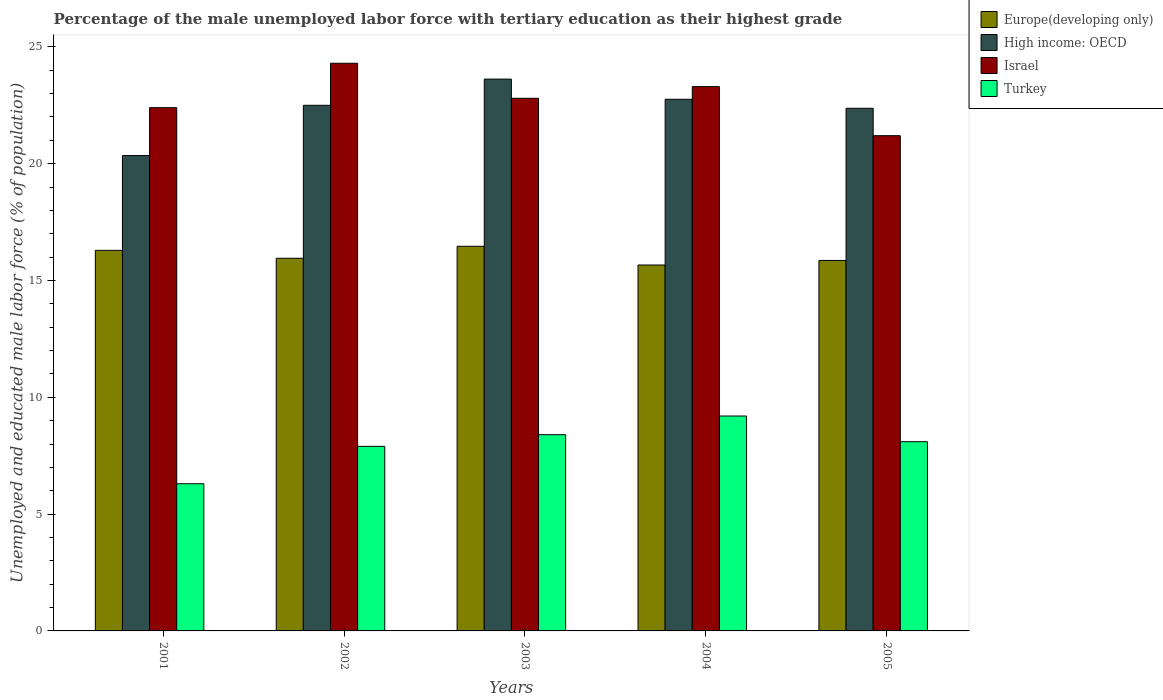How many different coloured bars are there?
Offer a terse response. 4. Are the number of bars per tick equal to the number of legend labels?
Offer a terse response. Yes. Are the number of bars on each tick of the X-axis equal?
Your answer should be very brief. Yes. How many bars are there on the 3rd tick from the left?
Make the answer very short. 4. What is the label of the 5th group of bars from the left?
Make the answer very short. 2005. In how many cases, is the number of bars for a given year not equal to the number of legend labels?
Your response must be concise. 0. What is the percentage of the unemployed male labor force with tertiary education in Europe(developing only) in 2002?
Provide a succinct answer. 15.95. Across all years, what is the maximum percentage of the unemployed male labor force with tertiary education in Turkey?
Your response must be concise. 9.2. Across all years, what is the minimum percentage of the unemployed male labor force with tertiary education in Israel?
Ensure brevity in your answer.  21.2. What is the total percentage of the unemployed male labor force with tertiary education in High income: OECD in the graph?
Provide a short and direct response. 111.6. What is the difference between the percentage of the unemployed male labor force with tertiary education in Israel in 2002 and that in 2005?
Offer a very short reply. 3.1. What is the difference between the percentage of the unemployed male labor force with tertiary education in Turkey in 2001 and the percentage of the unemployed male labor force with tertiary education in Europe(developing only) in 2002?
Your answer should be compact. -9.65. What is the average percentage of the unemployed male labor force with tertiary education in Israel per year?
Your answer should be compact. 22.8. In the year 2002, what is the difference between the percentage of the unemployed male labor force with tertiary education in High income: OECD and percentage of the unemployed male labor force with tertiary education in Europe(developing only)?
Make the answer very short. 6.55. In how many years, is the percentage of the unemployed male labor force with tertiary education in Turkey greater than 2 %?
Keep it short and to the point. 5. What is the ratio of the percentage of the unemployed male labor force with tertiary education in Israel in 2004 to that in 2005?
Your response must be concise. 1.1. Is the percentage of the unemployed male labor force with tertiary education in Europe(developing only) in 2002 less than that in 2005?
Your answer should be very brief. No. What is the difference between the highest and the second highest percentage of the unemployed male labor force with tertiary education in Turkey?
Provide a short and direct response. 0.8. What is the difference between the highest and the lowest percentage of the unemployed male labor force with tertiary education in Europe(developing only)?
Ensure brevity in your answer.  0.8. Is the sum of the percentage of the unemployed male labor force with tertiary education in Israel in 2003 and 2005 greater than the maximum percentage of the unemployed male labor force with tertiary education in Turkey across all years?
Give a very brief answer. Yes. Is it the case that in every year, the sum of the percentage of the unemployed male labor force with tertiary education in Europe(developing only) and percentage of the unemployed male labor force with tertiary education in Turkey is greater than the sum of percentage of the unemployed male labor force with tertiary education in High income: OECD and percentage of the unemployed male labor force with tertiary education in Israel?
Offer a terse response. No. What does the 2nd bar from the left in 2002 represents?
Your answer should be compact. High income: OECD. What does the 2nd bar from the right in 2002 represents?
Offer a very short reply. Israel. Is it the case that in every year, the sum of the percentage of the unemployed male labor force with tertiary education in High income: OECD and percentage of the unemployed male labor force with tertiary education in Europe(developing only) is greater than the percentage of the unemployed male labor force with tertiary education in Israel?
Offer a terse response. Yes. Are all the bars in the graph horizontal?
Your response must be concise. No. How many years are there in the graph?
Ensure brevity in your answer.  5. What is the difference between two consecutive major ticks on the Y-axis?
Offer a terse response. 5. Are the values on the major ticks of Y-axis written in scientific E-notation?
Your response must be concise. No. Does the graph contain any zero values?
Your answer should be very brief. No. Does the graph contain grids?
Provide a short and direct response. No. Where does the legend appear in the graph?
Your answer should be compact. Top right. What is the title of the graph?
Ensure brevity in your answer.  Percentage of the male unemployed labor force with tertiary education as their highest grade. What is the label or title of the Y-axis?
Your answer should be compact. Unemployed and educated male labor force (% of population). What is the Unemployed and educated male labor force (% of population) of Europe(developing only) in 2001?
Your answer should be compact. 16.29. What is the Unemployed and educated male labor force (% of population) in High income: OECD in 2001?
Ensure brevity in your answer.  20.35. What is the Unemployed and educated male labor force (% of population) of Israel in 2001?
Offer a very short reply. 22.4. What is the Unemployed and educated male labor force (% of population) of Turkey in 2001?
Ensure brevity in your answer.  6.3. What is the Unemployed and educated male labor force (% of population) of Europe(developing only) in 2002?
Your response must be concise. 15.95. What is the Unemployed and educated male labor force (% of population) of High income: OECD in 2002?
Make the answer very short. 22.5. What is the Unemployed and educated male labor force (% of population) of Israel in 2002?
Give a very brief answer. 24.3. What is the Unemployed and educated male labor force (% of population) of Turkey in 2002?
Offer a very short reply. 7.9. What is the Unemployed and educated male labor force (% of population) of Europe(developing only) in 2003?
Your response must be concise. 16.46. What is the Unemployed and educated male labor force (% of population) of High income: OECD in 2003?
Your response must be concise. 23.62. What is the Unemployed and educated male labor force (% of population) of Israel in 2003?
Offer a terse response. 22.8. What is the Unemployed and educated male labor force (% of population) in Turkey in 2003?
Provide a short and direct response. 8.4. What is the Unemployed and educated male labor force (% of population) of Europe(developing only) in 2004?
Your response must be concise. 15.66. What is the Unemployed and educated male labor force (% of population) in High income: OECD in 2004?
Your answer should be compact. 22.76. What is the Unemployed and educated male labor force (% of population) in Israel in 2004?
Make the answer very short. 23.3. What is the Unemployed and educated male labor force (% of population) of Turkey in 2004?
Keep it short and to the point. 9.2. What is the Unemployed and educated male labor force (% of population) of Europe(developing only) in 2005?
Provide a short and direct response. 15.86. What is the Unemployed and educated male labor force (% of population) of High income: OECD in 2005?
Give a very brief answer. 22.37. What is the Unemployed and educated male labor force (% of population) of Israel in 2005?
Keep it short and to the point. 21.2. What is the Unemployed and educated male labor force (% of population) of Turkey in 2005?
Your answer should be compact. 8.1. Across all years, what is the maximum Unemployed and educated male labor force (% of population) of Europe(developing only)?
Provide a short and direct response. 16.46. Across all years, what is the maximum Unemployed and educated male labor force (% of population) in High income: OECD?
Ensure brevity in your answer.  23.62. Across all years, what is the maximum Unemployed and educated male labor force (% of population) in Israel?
Your answer should be very brief. 24.3. Across all years, what is the maximum Unemployed and educated male labor force (% of population) of Turkey?
Ensure brevity in your answer.  9.2. Across all years, what is the minimum Unemployed and educated male labor force (% of population) of Europe(developing only)?
Provide a short and direct response. 15.66. Across all years, what is the minimum Unemployed and educated male labor force (% of population) in High income: OECD?
Your answer should be very brief. 20.35. Across all years, what is the minimum Unemployed and educated male labor force (% of population) of Israel?
Offer a terse response. 21.2. Across all years, what is the minimum Unemployed and educated male labor force (% of population) of Turkey?
Give a very brief answer. 6.3. What is the total Unemployed and educated male labor force (% of population) in Europe(developing only) in the graph?
Offer a terse response. 80.23. What is the total Unemployed and educated male labor force (% of population) in High income: OECD in the graph?
Your answer should be compact. 111.6. What is the total Unemployed and educated male labor force (% of population) in Israel in the graph?
Provide a short and direct response. 114. What is the total Unemployed and educated male labor force (% of population) in Turkey in the graph?
Provide a short and direct response. 39.9. What is the difference between the Unemployed and educated male labor force (% of population) of Europe(developing only) in 2001 and that in 2002?
Your answer should be compact. 0.34. What is the difference between the Unemployed and educated male labor force (% of population) of High income: OECD in 2001 and that in 2002?
Provide a short and direct response. -2.15. What is the difference between the Unemployed and educated male labor force (% of population) in Israel in 2001 and that in 2002?
Offer a terse response. -1.9. What is the difference between the Unemployed and educated male labor force (% of population) in Europe(developing only) in 2001 and that in 2003?
Your answer should be compact. -0.17. What is the difference between the Unemployed and educated male labor force (% of population) in High income: OECD in 2001 and that in 2003?
Keep it short and to the point. -3.27. What is the difference between the Unemployed and educated male labor force (% of population) of Turkey in 2001 and that in 2003?
Keep it short and to the point. -2.1. What is the difference between the Unemployed and educated male labor force (% of population) in Europe(developing only) in 2001 and that in 2004?
Your response must be concise. 0.63. What is the difference between the Unemployed and educated male labor force (% of population) of High income: OECD in 2001 and that in 2004?
Ensure brevity in your answer.  -2.41. What is the difference between the Unemployed and educated male labor force (% of population) in Israel in 2001 and that in 2004?
Make the answer very short. -0.9. What is the difference between the Unemployed and educated male labor force (% of population) of Europe(developing only) in 2001 and that in 2005?
Offer a terse response. 0.43. What is the difference between the Unemployed and educated male labor force (% of population) of High income: OECD in 2001 and that in 2005?
Make the answer very short. -2.02. What is the difference between the Unemployed and educated male labor force (% of population) of Israel in 2001 and that in 2005?
Provide a succinct answer. 1.2. What is the difference between the Unemployed and educated male labor force (% of population) of Turkey in 2001 and that in 2005?
Give a very brief answer. -1.8. What is the difference between the Unemployed and educated male labor force (% of population) of Europe(developing only) in 2002 and that in 2003?
Your answer should be very brief. -0.51. What is the difference between the Unemployed and educated male labor force (% of population) of High income: OECD in 2002 and that in 2003?
Provide a succinct answer. -1.12. What is the difference between the Unemployed and educated male labor force (% of population) in Turkey in 2002 and that in 2003?
Offer a very short reply. -0.5. What is the difference between the Unemployed and educated male labor force (% of population) in Europe(developing only) in 2002 and that in 2004?
Your answer should be compact. 0.29. What is the difference between the Unemployed and educated male labor force (% of population) of High income: OECD in 2002 and that in 2004?
Offer a very short reply. -0.26. What is the difference between the Unemployed and educated male labor force (% of population) in Israel in 2002 and that in 2004?
Offer a very short reply. 1. What is the difference between the Unemployed and educated male labor force (% of population) in Turkey in 2002 and that in 2004?
Provide a succinct answer. -1.3. What is the difference between the Unemployed and educated male labor force (% of population) of Europe(developing only) in 2002 and that in 2005?
Your answer should be compact. 0.09. What is the difference between the Unemployed and educated male labor force (% of population) in High income: OECD in 2002 and that in 2005?
Make the answer very short. 0.13. What is the difference between the Unemployed and educated male labor force (% of population) in Israel in 2002 and that in 2005?
Offer a very short reply. 3.1. What is the difference between the Unemployed and educated male labor force (% of population) in Turkey in 2002 and that in 2005?
Your answer should be very brief. -0.2. What is the difference between the Unemployed and educated male labor force (% of population) of Europe(developing only) in 2003 and that in 2004?
Provide a short and direct response. 0.8. What is the difference between the Unemployed and educated male labor force (% of population) of High income: OECD in 2003 and that in 2004?
Provide a short and direct response. 0.86. What is the difference between the Unemployed and educated male labor force (% of population) in Europe(developing only) in 2003 and that in 2005?
Provide a short and direct response. 0.61. What is the difference between the Unemployed and educated male labor force (% of population) in High income: OECD in 2003 and that in 2005?
Your answer should be very brief. 1.25. What is the difference between the Unemployed and educated male labor force (% of population) in Turkey in 2003 and that in 2005?
Offer a terse response. 0.3. What is the difference between the Unemployed and educated male labor force (% of population) in Europe(developing only) in 2004 and that in 2005?
Offer a very short reply. -0.2. What is the difference between the Unemployed and educated male labor force (% of population) in High income: OECD in 2004 and that in 2005?
Offer a terse response. 0.39. What is the difference between the Unemployed and educated male labor force (% of population) in Israel in 2004 and that in 2005?
Give a very brief answer. 2.1. What is the difference between the Unemployed and educated male labor force (% of population) in Turkey in 2004 and that in 2005?
Make the answer very short. 1.1. What is the difference between the Unemployed and educated male labor force (% of population) of Europe(developing only) in 2001 and the Unemployed and educated male labor force (% of population) of High income: OECD in 2002?
Your answer should be compact. -6.21. What is the difference between the Unemployed and educated male labor force (% of population) of Europe(developing only) in 2001 and the Unemployed and educated male labor force (% of population) of Israel in 2002?
Offer a very short reply. -8.01. What is the difference between the Unemployed and educated male labor force (% of population) in Europe(developing only) in 2001 and the Unemployed and educated male labor force (% of population) in Turkey in 2002?
Offer a terse response. 8.39. What is the difference between the Unemployed and educated male labor force (% of population) in High income: OECD in 2001 and the Unemployed and educated male labor force (% of population) in Israel in 2002?
Make the answer very short. -3.95. What is the difference between the Unemployed and educated male labor force (% of population) in High income: OECD in 2001 and the Unemployed and educated male labor force (% of population) in Turkey in 2002?
Keep it short and to the point. 12.45. What is the difference between the Unemployed and educated male labor force (% of population) of Israel in 2001 and the Unemployed and educated male labor force (% of population) of Turkey in 2002?
Your response must be concise. 14.5. What is the difference between the Unemployed and educated male labor force (% of population) of Europe(developing only) in 2001 and the Unemployed and educated male labor force (% of population) of High income: OECD in 2003?
Offer a terse response. -7.33. What is the difference between the Unemployed and educated male labor force (% of population) in Europe(developing only) in 2001 and the Unemployed and educated male labor force (% of population) in Israel in 2003?
Your answer should be very brief. -6.51. What is the difference between the Unemployed and educated male labor force (% of population) in Europe(developing only) in 2001 and the Unemployed and educated male labor force (% of population) in Turkey in 2003?
Your answer should be very brief. 7.89. What is the difference between the Unemployed and educated male labor force (% of population) in High income: OECD in 2001 and the Unemployed and educated male labor force (% of population) in Israel in 2003?
Provide a succinct answer. -2.45. What is the difference between the Unemployed and educated male labor force (% of population) of High income: OECD in 2001 and the Unemployed and educated male labor force (% of population) of Turkey in 2003?
Your answer should be compact. 11.95. What is the difference between the Unemployed and educated male labor force (% of population) in Europe(developing only) in 2001 and the Unemployed and educated male labor force (% of population) in High income: OECD in 2004?
Ensure brevity in your answer.  -6.47. What is the difference between the Unemployed and educated male labor force (% of population) of Europe(developing only) in 2001 and the Unemployed and educated male labor force (% of population) of Israel in 2004?
Give a very brief answer. -7.01. What is the difference between the Unemployed and educated male labor force (% of population) in Europe(developing only) in 2001 and the Unemployed and educated male labor force (% of population) in Turkey in 2004?
Ensure brevity in your answer.  7.09. What is the difference between the Unemployed and educated male labor force (% of population) in High income: OECD in 2001 and the Unemployed and educated male labor force (% of population) in Israel in 2004?
Offer a terse response. -2.95. What is the difference between the Unemployed and educated male labor force (% of population) in High income: OECD in 2001 and the Unemployed and educated male labor force (% of population) in Turkey in 2004?
Your answer should be very brief. 11.15. What is the difference between the Unemployed and educated male labor force (% of population) of Israel in 2001 and the Unemployed and educated male labor force (% of population) of Turkey in 2004?
Your answer should be compact. 13.2. What is the difference between the Unemployed and educated male labor force (% of population) in Europe(developing only) in 2001 and the Unemployed and educated male labor force (% of population) in High income: OECD in 2005?
Offer a terse response. -6.08. What is the difference between the Unemployed and educated male labor force (% of population) of Europe(developing only) in 2001 and the Unemployed and educated male labor force (% of population) of Israel in 2005?
Provide a short and direct response. -4.91. What is the difference between the Unemployed and educated male labor force (% of population) in Europe(developing only) in 2001 and the Unemployed and educated male labor force (% of population) in Turkey in 2005?
Your answer should be very brief. 8.19. What is the difference between the Unemployed and educated male labor force (% of population) of High income: OECD in 2001 and the Unemployed and educated male labor force (% of population) of Israel in 2005?
Keep it short and to the point. -0.85. What is the difference between the Unemployed and educated male labor force (% of population) in High income: OECD in 2001 and the Unemployed and educated male labor force (% of population) in Turkey in 2005?
Your response must be concise. 12.25. What is the difference between the Unemployed and educated male labor force (% of population) in Israel in 2001 and the Unemployed and educated male labor force (% of population) in Turkey in 2005?
Provide a succinct answer. 14.3. What is the difference between the Unemployed and educated male labor force (% of population) of Europe(developing only) in 2002 and the Unemployed and educated male labor force (% of population) of High income: OECD in 2003?
Make the answer very short. -7.67. What is the difference between the Unemployed and educated male labor force (% of population) in Europe(developing only) in 2002 and the Unemployed and educated male labor force (% of population) in Israel in 2003?
Your response must be concise. -6.85. What is the difference between the Unemployed and educated male labor force (% of population) of Europe(developing only) in 2002 and the Unemployed and educated male labor force (% of population) of Turkey in 2003?
Offer a very short reply. 7.55. What is the difference between the Unemployed and educated male labor force (% of population) of High income: OECD in 2002 and the Unemployed and educated male labor force (% of population) of Israel in 2003?
Provide a succinct answer. -0.3. What is the difference between the Unemployed and educated male labor force (% of population) in High income: OECD in 2002 and the Unemployed and educated male labor force (% of population) in Turkey in 2003?
Make the answer very short. 14.1. What is the difference between the Unemployed and educated male labor force (% of population) of Europe(developing only) in 2002 and the Unemployed and educated male labor force (% of population) of High income: OECD in 2004?
Provide a short and direct response. -6.81. What is the difference between the Unemployed and educated male labor force (% of population) of Europe(developing only) in 2002 and the Unemployed and educated male labor force (% of population) of Israel in 2004?
Ensure brevity in your answer.  -7.35. What is the difference between the Unemployed and educated male labor force (% of population) in Europe(developing only) in 2002 and the Unemployed and educated male labor force (% of population) in Turkey in 2004?
Your answer should be very brief. 6.75. What is the difference between the Unemployed and educated male labor force (% of population) of High income: OECD in 2002 and the Unemployed and educated male labor force (% of population) of Israel in 2004?
Provide a succinct answer. -0.8. What is the difference between the Unemployed and educated male labor force (% of population) of High income: OECD in 2002 and the Unemployed and educated male labor force (% of population) of Turkey in 2004?
Give a very brief answer. 13.3. What is the difference between the Unemployed and educated male labor force (% of population) of Europe(developing only) in 2002 and the Unemployed and educated male labor force (% of population) of High income: OECD in 2005?
Offer a very short reply. -6.42. What is the difference between the Unemployed and educated male labor force (% of population) in Europe(developing only) in 2002 and the Unemployed and educated male labor force (% of population) in Israel in 2005?
Offer a terse response. -5.25. What is the difference between the Unemployed and educated male labor force (% of population) of Europe(developing only) in 2002 and the Unemployed and educated male labor force (% of population) of Turkey in 2005?
Keep it short and to the point. 7.85. What is the difference between the Unemployed and educated male labor force (% of population) in High income: OECD in 2002 and the Unemployed and educated male labor force (% of population) in Israel in 2005?
Your response must be concise. 1.3. What is the difference between the Unemployed and educated male labor force (% of population) in High income: OECD in 2002 and the Unemployed and educated male labor force (% of population) in Turkey in 2005?
Your response must be concise. 14.4. What is the difference between the Unemployed and educated male labor force (% of population) of Europe(developing only) in 2003 and the Unemployed and educated male labor force (% of population) of High income: OECD in 2004?
Your answer should be very brief. -6.29. What is the difference between the Unemployed and educated male labor force (% of population) of Europe(developing only) in 2003 and the Unemployed and educated male labor force (% of population) of Israel in 2004?
Make the answer very short. -6.84. What is the difference between the Unemployed and educated male labor force (% of population) of Europe(developing only) in 2003 and the Unemployed and educated male labor force (% of population) of Turkey in 2004?
Make the answer very short. 7.26. What is the difference between the Unemployed and educated male labor force (% of population) in High income: OECD in 2003 and the Unemployed and educated male labor force (% of population) in Israel in 2004?
Your answer should be compact. 0.32. What is the difference between the Unemployed and educated male labor force (% of population) of High income: OECD in 2003 and the Unemployed and educated male labor force (% of population) of Turkey in 2004?
Provide a succinct answer. 14.42. What is the difference between the Unemployed and educated male labor force (% of population) in Europe(developing only) in 2003 and the Unemployed and educated male labor force (% of population) in High income: OECD in 2005?
Provide a succinct answer. -5.91. What is the difference between the Unemployed and educated male labor force (% of population) in Europe(developing only) in 2003 and the Unemployed and educated male labor force (% of population) in Israel in 2005?
Your response must be concise. -4.74. What is the difference between the Unemployed and educated male labor force (% of population) in Europe(developing only) in 2003 and the Unemployed and educated male labor force (% of population) in Turkey in 2005?
Provide a succinct answer. 8.36. What is the difference between the Unemployed and educated male labor force (% of population) of High income: OECD in 2003 and the Unemployed and educated male labor force (% of population) of Israel in 2005?
Keep it short and to the point. 2.42. What is the difference between the Unemployed and educated male labor force (% of population) of High income: OECD in 2003 and the Unemployed and educated male labor force (% of population) of Turkey in 2005?
Offer a terse response. 15.52. What is the difference between the Unemployed and educated male labor force (% of population) in Israel in 2003 and the Unemployed and educated male labor force (% of population) in Turkey in 2005?
Make the answer very short. 14.7. What is the difference between the Unemployed and educated male labor force (% of population) in Europe(developing only) in 2004 and the Unemployed and educated male labor force (% of population) in High income: OECD in 2005?
Make the answer very short. -6.71. What is the difference between the Unemployed and educated male labor force (% of population) of Europe(developing only) in 2004 and the Unemployed and educated male labor force (% of population) of Israel in 2005?
Ensure brevity in your answer.  -5.54. What is the difference between the Unemployed and educated male labor force (% of population) of Europe(developing only) in 2004 and the Unemployed and educated male labor force (% of population) of Turkey in 2005?
Provide a succinct answer. 7.56. What is the difference between the Unemployed and educated male labor force (% of population) in High income: OECD in 2004 and the Unemployed and educated male labor force (% of population) in Israel in 2005?
Ensure brevity in your answer.  1.56. What is the difference between the Unemployed and educated male labor force (% of population) of High income: OECD in 2004 and the Unemployed and educated male labor force (% of population) of Turkey in 2005?
Provide a succinct answer. 14.66. What is the difference between the Unemployed and educated male labor force (% of population) in Israel in 2004 and the Unemployed and educated male labor force (% of population) in Turkey in 2005?
Your answer should be compact. 15.2. What is the average Unemployed and educated male labor force (% of population) of Europe(developing only) per year?
Keep it short and to the point. 16.05. What is the average Unemployed and educated male labor force (% of population) in High income: OECD per year?
Ensure brevity in your answer.  22.32. What is the average Unemployed and educated male labor force (% of population) of Israel per year?
Keep it short and to the point. 22.8. What is the average Unemployed and educated male labor force (% of population) of Turkey per year?
Provide a succinct answer. 7.98. In the year 2001, what is the difference between the Unemployed and educated male labor force (% of population) in Europe(developing only) and Unemployed and educated male labor force (% of population) in High income: OECD?
Provide a short and direct response. -4.06. In the year 2001, what is the difference between the Unemployed and educated male labor force (% of population) in Europe(developing only) and Unemployed and educated male labor force (% of population) in Israel?
Keep it short and to the point. -6.11. In the year 2001, what is the difference between the Unemployed and educated male labor force (% of population) of Europe(developing only) and Unemployed and educated male labor force (% of population) of Turkey?
Your response must be concise. 9.99. In the year 2001, what is the difference between the Unemployed and educated male labor force (% of population) in High income: OECD and Unemployed and educated male labor force (% of population) in Israel?
Give a very brief answer. -2.05. In the year 2001, what is the difference between the Unemployed and educated male labor force (% of population) in High income: OECD and Unemployed and educated male labor force (% of population) in Turkey?
Provide a succinct answer. 14.05. In the year 2001, what is the difference between the Unemployed and educated male labor force (% of population) of Israel and Unemployed and educated male labor force (% of population) of Turkey?
Ensure brevity in your answer.  16.1. In the year 2002, what is the difference between the Unemployed and educated male labor force (% of population) of Europe(developing only) and Unemployed and educated male labor force (% of population) of High income: OECD?
Your answer should be compact. -6.55. In the year 2002, what is the difference between the Unemployed and educated male labor force (% of population) of Europe(developing only) and Unemployed and educated male labor force (% of population) of Israel?
Give a very brief answer. -8.35. In the year 2002, what is the difference between the Unemployed and educated male labor force (% of population) of Europe(developing only) and Unemployed and educated male labor force (% of population) of Turkey?
Offer a terse response. 8.05. In the year 2002, what is the difference between the Unemployed and educated male labor force (% of population) in High income: OECD and Unemployed and educated male labor force (% of population) in Israel?
Ensure brevity in your answer.  -1.8. In the year 2002, what is the difference between the Unemployed and educated male labor force (% of population) in High income: OECD and Unemployed and educated male labor force (% of population) in Turkey?
Your answer should be very brief. 14.6. In the year 2003, what is the difference between the Unemployed and educated male labor force (% of population) in Europe(developing only) and Unemployed and educated male labor force (% of population) in High income: OECD?
Keep it short and to the point. -7.16. In the year 2003, what is the difference between the Unemployed and educated male labor force (% of population) in Europe(developing only) and Unemployed and educated male labor force (% of population) in Israel?
Your response must be concise. -6.34. In the year 2003, what is the difference between the Unemployed and educated male labor force (% of population) in Europe(developing only) and Unemployed and educated male labor force (% of population) in Turkey?
Provide a short and direct response. 8.06. In the year 2003, what is the difference between the Unemployed and educated male labor force (% of population) in High income: OECD and Unemployed and educated male labor force (% of population) in Israel?
Make the answer very short. 0.82. In the year 2003, what is the difference between the Unemployed and educated male labor force (% of population) in High income: OECD and Unemployed and educated male labor force (% of population) in Turkey?
Provide a short and direct response. 15.22. In the year 2003, what is the difference between the Unemployed and educated male labor force (% of population) in Israel and Unemployed and educated male labor force (% of population) in Turkey?
Offer a terse response. 14.4. In the year 2004, what is the difference between the Unemployed and educated male labor force (% of population) of Europe(developing only) and Unemployed and educated male labor force (% of population) of High income: OECD?
Make the answer very short. -7.09. In the year 2004, what is the difference between the Unemployed and educated male labor force (% of population) in Europe(developing only) and Unemployed and educated male labor force (% of population) in Israel?
Keep it short and to the point. -7.64. In the year 2004, what is the difference between the Unemployed and educated male labor force (% of population) in Europe(developing only) and Unemployed and educated male labor force (% of population) in Turkey?
Your answer should be compact. 6.46. In the year 2004, what is the difference between the Unemployed and educated male labor force (% of population) of High income: OECD and Unemployed and educated male labor force (% of population) of Israel?
Make the answer very short. -0.54. In the year 2004, what is the difference between the Unemployed and educated male labor force (% of population) of High income: OECD and Unemployed and educated male labor force (% of population) of Turkey?
Your answer should be compact. 13.56. In the year 2004, what is the difference between the Unemployed and educated male labor force (% of population) in Israel and Unemployed and educated male labor force (% of population) in Turkey?
Your answer should be compact. 14.1. In the year 2005, what is the difference between the Unemployed and educated male labor force (% of population) of Europe(developing only) and Unemployed and educated male labor force (% of population) of High income: OECD?
Offer a very short reply. -6.51. In the year 2005, what is the difference between the Unemployed and educated male labor force (% of population) of Europe(developing only) and Unemployed and educated male labor force (% of population) of Israel?
Your answer should be very brief. -5.34. In the year 2005, what is the difference between the Unemployed and educated male labor force (% of population) in Europe(developing only) and Unemployed and educated male labor force (% of population) in Turkey?
Make the answer very short. 7.76. In the year 2005, what is the difference between the Unemployed and educated male labor force (% of population) of High income: OECD and Unemployed and educated male labor force (% of population) of Israel?
Provide a succinct answer. 1.17. In the year 2005, what is the difference between the Unemployed and educated male labor force (% of population) in High income: OECD and Unemployed and educated male labor force (% of population) in Turkey?
Offer a very short reply. 14.27. In the year 2005, what is the difference between the Unemployed and educated male labor force (% of population) in Israel and Unemployed and educated male labor force (% of population) in Turkey?
Your response must be concise. 13.1. What is the ratio of the Unemployed and educated male labor force (% of population) in Europe(developing only) in 2001 to that in 2002?
Offer a terse response. 1.02. What is the ratio of the Unemployed and educated male labor force (% of population) of High income: OECD in 2001 to that in 2002?
Your response must be concise. 0.9. What is the ratio of the Unemployed and educated male labor force (% of population) in Israel in 2001 to that in 2002?
Provide a succinct answer. 0.92. What is the ratio of the Unemployed and educated male labor force (% of population) of Turkey in 2001 to that in 2002?
Offer a very short reply. 0.8. What is the ratio of the Unemployed and educated male labor force (% of population) of High income: OECD in 2001 to that in 2003?
Offer a terse response. 0.86. What is the ratio of the Unemployed and educated male labor force (% of population) of Israel in 2001 to that in 2003?
Make the answer very short. 0.98. What is the ratio of the Unemployed and educated male labor force (% of population) in Turkey in 2001 to that in 2003?
Offer a very short reply. 0.75. What is the ratio of the Unemployed and educated male labor force (% of population) of Europe(developing only) in 2001 to that in 2004?
Offer a terse response. 1.04. What is the ratio of the Unemployed and educated male labor force (% of population) in High income: OECD in 2001 to that in 2004?
Make the answer very short. 0.89. What is the ratio of the Unemployed and educated male labor force (% of population) of Israel in 2001 to that in 2004?
Offer a very short reply. 0.96. What is the ratio of the Unemployed and educated male labor force (% of population) in Turkey in 2001 to that in 2004?
Ensure brevity in your answer.  0.68. What is the ratio of the Unemployed and educated male labor force (% of population) of Europe(developing only) in 2001 to that in 2005?
Offer a very short reply. 1.03. What is the ratio of the Unemployed and educated male labor force (% of population) of High income: OECD in 2001 to that in 2005?
Ensure brevity in your answer.  0.91. What is the ratio of the Unemployed and educated male labor force (% of population) of Israel in 2001 to that in 2005?
Offer a very short reply. 1.06. What is the ratio of the Unemployed and educated male labor force (% of population) in Europe(developing only) in 2002 to that in 2003?
Offer a very short reply. 0.97. What is the ratio of the Unemployed and educated male labor force (% of population) of High income: OECD in 2002 to that in 2003?
Offer a terse response. 0.95. What is the ratio of the Unemployed and educated male labor force (% of population) of Israel in 2002 to that in 2003?
Your answer should be compact. 1.07. What is the ratio of the Unemployed and educated male labor force (% of population) of Turkey in 2002 to that in 2003?
Offer a very short reply. 0.94. What is the ratio of the Unemployed and educated male labor force (% of population) in Europe(developing only) in 2002 to that in 2004?
Your response must be concise. 1.02. What is the ratio of the Unemployed and educated male labor force (% of population) of High income: OECD in 2002 to that in 2004?
Give a very brief answer. 0.99. What is the ratio of the Unemployed and educated male labor force (% of population) of Israel in 2002 to that in 2004?
Ensure brevity in your answer.  1.04. What is the ratio of the Unemployed and educated male labor force (% of population) of Turkey in 2002 to that in 2004?
Keep it short and to the point. 0.86. What is the ratio of the Unemployed and educated male labor force (% of population) in Europe(developing only) in 2002 to that in 2005?
Keep it short and to the point. 1.01. What is the ratio of the Unemployed and educated male labor force (% of population) of Israel in 2002 to that in 2005?
Provide a short and direct response. 1.15. What is the ratio of the Unemployed and educated male labor force (% of population) of Turkey in 2002 to that in 2005?
Keep it short and to the point. 0.98. What is the ratio of the Unemployed and educated male labor force (% of population) of Europe(developing only) in 2003 to that in 2004?
Make the answer very short. 1.05. What is the ratio of the Unemployed and educated male labor force (% of population) of High income: OECD in 2003 to that in 2004?
Keep it short and to the point. 1.04. What is the ratio of the Unemployed and educated male labor force (% of population) in Israel in 2003 to that in 2004?
Your answer should be very brief. 0.98. What is the ratio of the Unemployed and educated male labor force (% of population) of Europe(developing only) in 2003 to that in 2005?
Offer a terse response. 1.04. What is the ratio of the Unemployed and educated male labor force (% of population) of High income: OECD in 2003 to that in 2005?
Offer a terse response. 1.06. What is the ratio of the Unemployed and educated male labor force (% of population) of Israel in 2003 to that in 2005?
Provide a succinct answer. 1.08. What is the ratio of the Unemployed and educated male labor force (% of population) in Turkey in 2003 to that in 2005?
Give a very brief answer. 1.04. What is the ratio of the Unemployed and educated male labor force (% of population) of High income: OECD in 2004 to that in 2005?
Provide a succinct answer. 1.02. What is the ratio of the Unemployed and educated male labor force (% of population) of Israel in 2004 to that in 2005?
Provide a short and direct response. 1.1. What is the ratio of the Unemployed and educated male labor force (% of population) in Turkey in 2004 to that in 2005?
Provide a succinct answer. 1.14. What is the difference between the highest and the second highest Unemployed and educated male labor force (% of population) in Europe(developing only)?
Provide a short and direct response. 0.17. What is the difference between the highest and the second highest Unemployed and educated male labor force (% of population) in High income: OECD?
Keep it short and to the point. 0.86. What is the difference between the highest and the second highest Unemployed and educated male labor force (% of population) of Israel?
Make the answer very short. 1. What is the difference between the highest and the second highest Unemployed and educated male labor force (% of population) of Turkey?
Your response must be concise. 0.8. What is the difference between the highest and the lowest Unemployed and educated male labor force (% of population) in Europe(developing only)?
Provide a short and direct response. 0.8. What is the difference between the highest and the lowest Unemployed and educated male labor force (% of population) of High income: OECD?
Your response must be concise. 3.27. What is the difference between the highest and the lowest Unemployed and educated male labor force (% of population) in Israel?
Provide a short and direct response. 3.1. What is the difference between the highest and the lowest Unemployed and educated male labor force (% of population) in Turkey?
Your response must be concise. 2.9. 